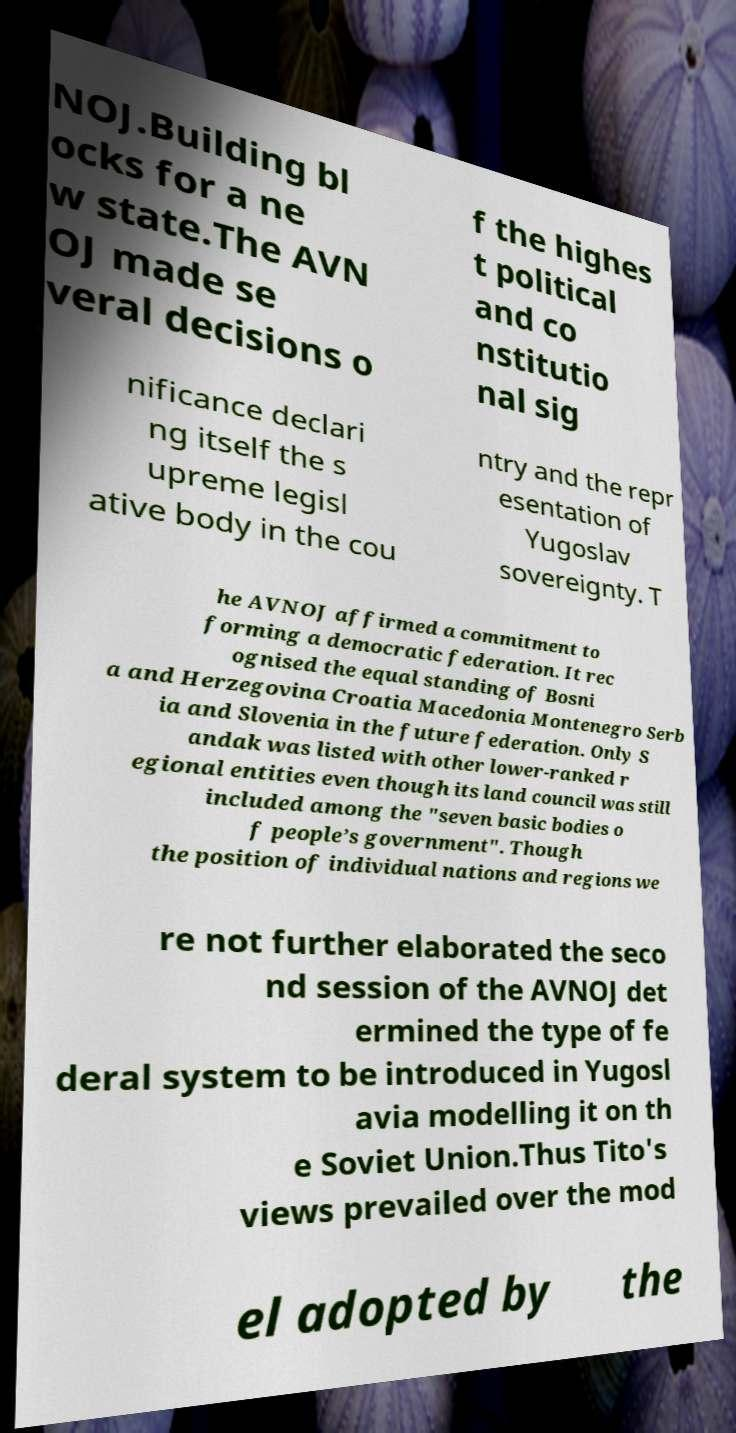I need the written content from this picture converted into text. Can you do that? NOJ.Building bl ocks for a ne w state.The AVN OJ made se veral decisions o f the highes t political and co nstitutio nal sig nificance declari ng itself the s upreme legisl ative body in the cou ntry and the repr esentation of Yugoslav sovereignty. T he AVNOJ affirmed a commitment to forming a democratic federation. It rec ognised the equal standing of Bosni a and Herzegovina Croatia Macedonia Montenegro Serb ia and Slovenia in the future federation. Only S andak was listed with other lower-ranked r egional entities even though its land council was still included among the "seven basic bodies o f people’s government". Though the position of individual nations and regions we re not further elaborated the seco nd session of the AVNOJ det ermined the type of fe deral system to be introduced in Yugosl avia modelling it on th e Soviet Union.Thus Tito's views prevailed over the mod el adopted by the 